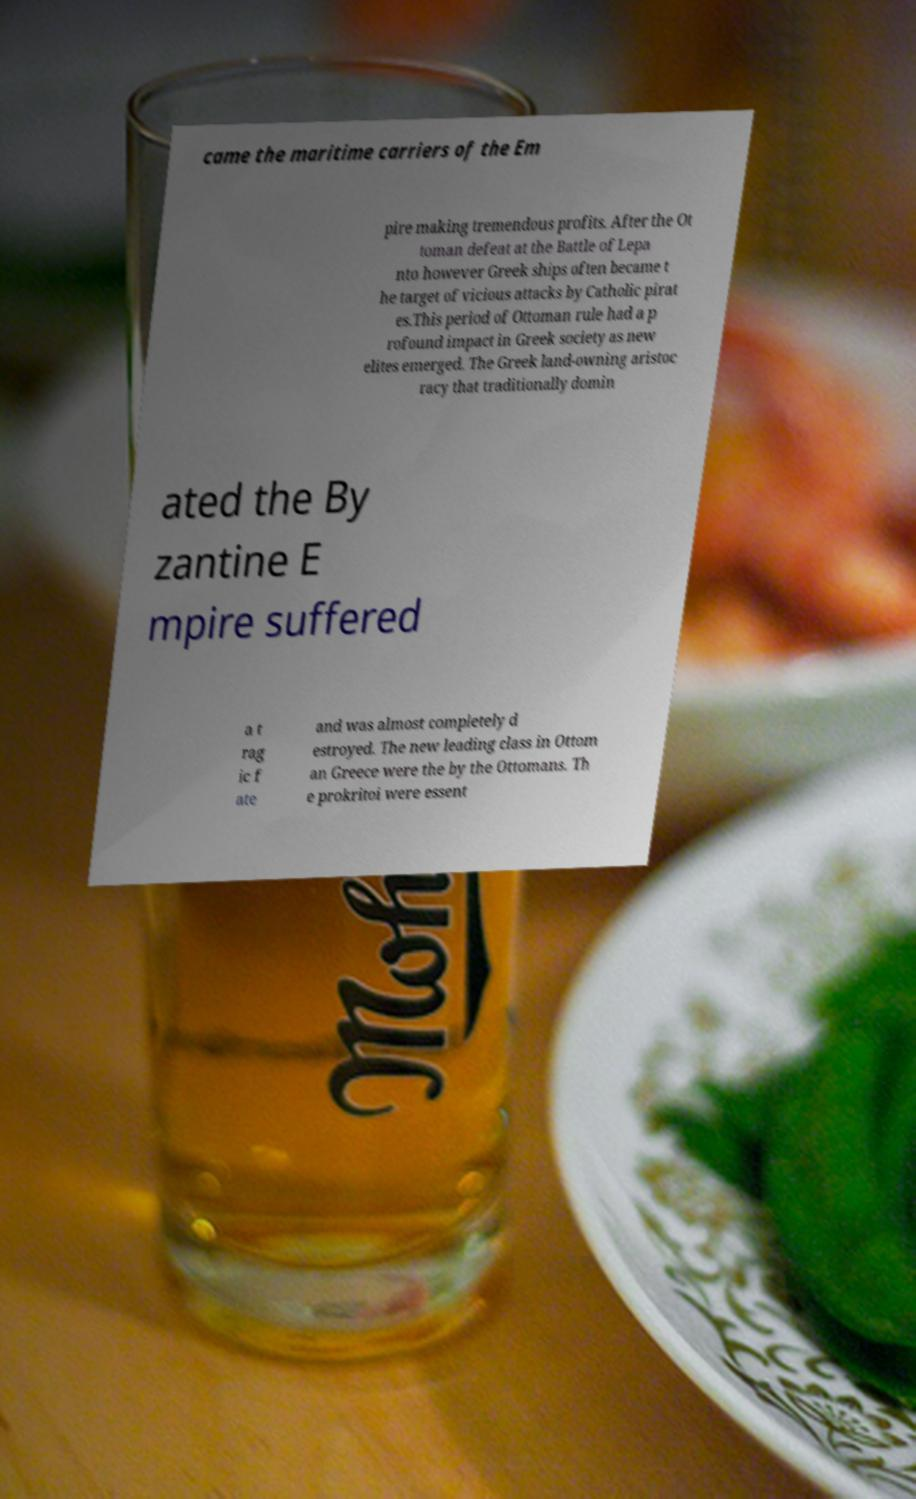Please read and relay the text visible in this image. What does it say? came the maritime carriers of the Em pire making tremendous profits. After the Ot toman defeat at the Battle of Lepa nto however Greek ships often became t he target of vicious attacks by Catholic pirat es.This period of Ottoman rule had a p rofound impact in Greek society as new elites emerged. The Greek land-owning aristoc racy that traditionally domin ated the By zantine E mpire suffered a t rag ic f ate and was almost completely d estroyed. The new leading class in Ottom an Greece were the by the Ottomans. Th e prokritoi were essent 